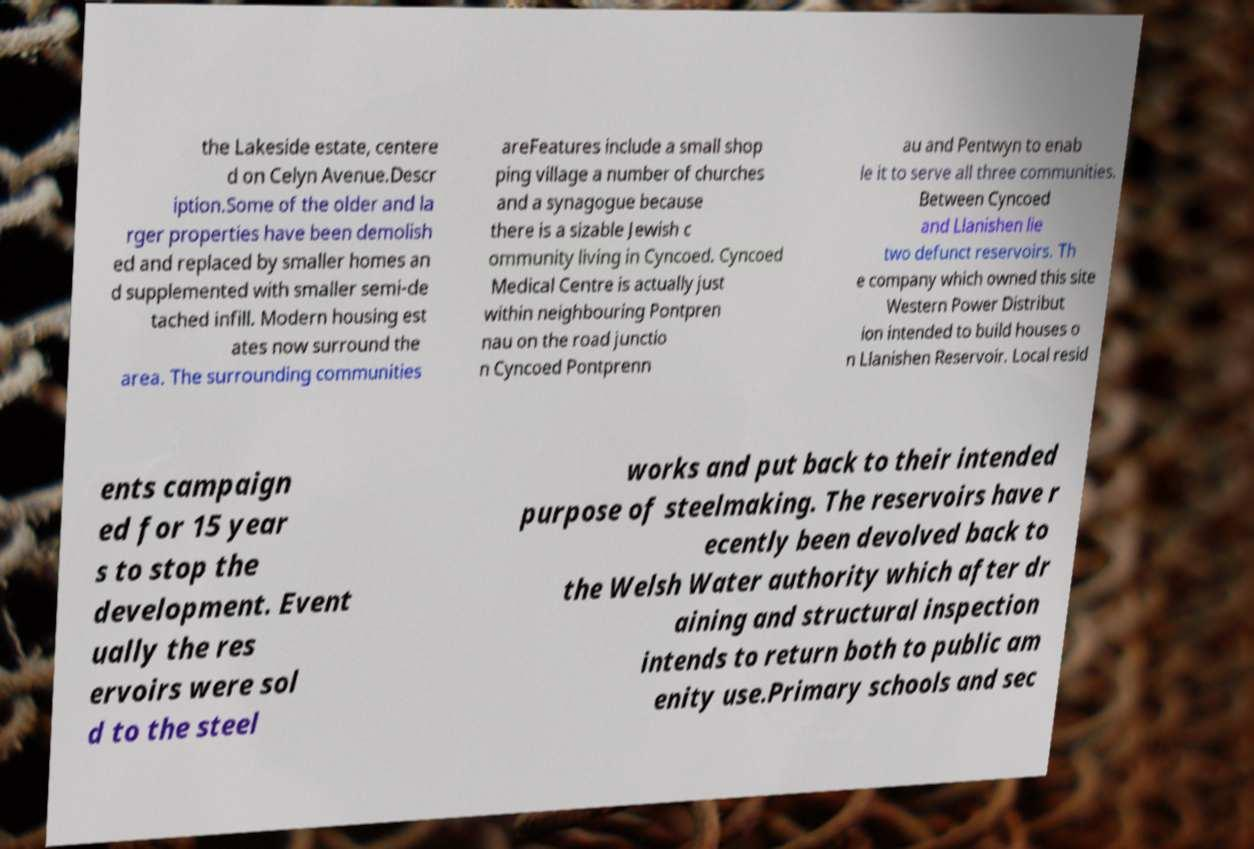What messages or text are displayed in this image? I need them in a readable, typed format. the Lakeside estate, centere d on Celyn Avenue.Descr iption.Some of the older and la rger properties have been demolish ed and replaced by smaller homes an d supplemented with smaller semi-de tached infill. Modern housing est ates now surround the area. The surrounding communities areFeatures include a small shop ping village a number of churches and a synagogue because there is a sizable Jewish c ommunity living in Cyncoed. Cyncoed Medical Centre is actually just within neighbouring Pontpren nau on the road junctio n Cyncoed Pontprenn au and Pentwyn to enab le it to serve all three communities. Between Cyncoed and Llanishen lie two defunct reservoirs. Th e company which owned this site Western Power Distribut ion intended to build houses o n Llanishen Reservoir. Local resid ents campaign ed for 15 year s to stop the development. Event ually the res ervoirs were sol d to the steel works and put back to their intended purpose of steelmaking. The reservoirs have r ecently been devolved back to the Welsh Water authority which after dr aining and structural inspection intends to return both to public am enity use.Primary schools and sec 